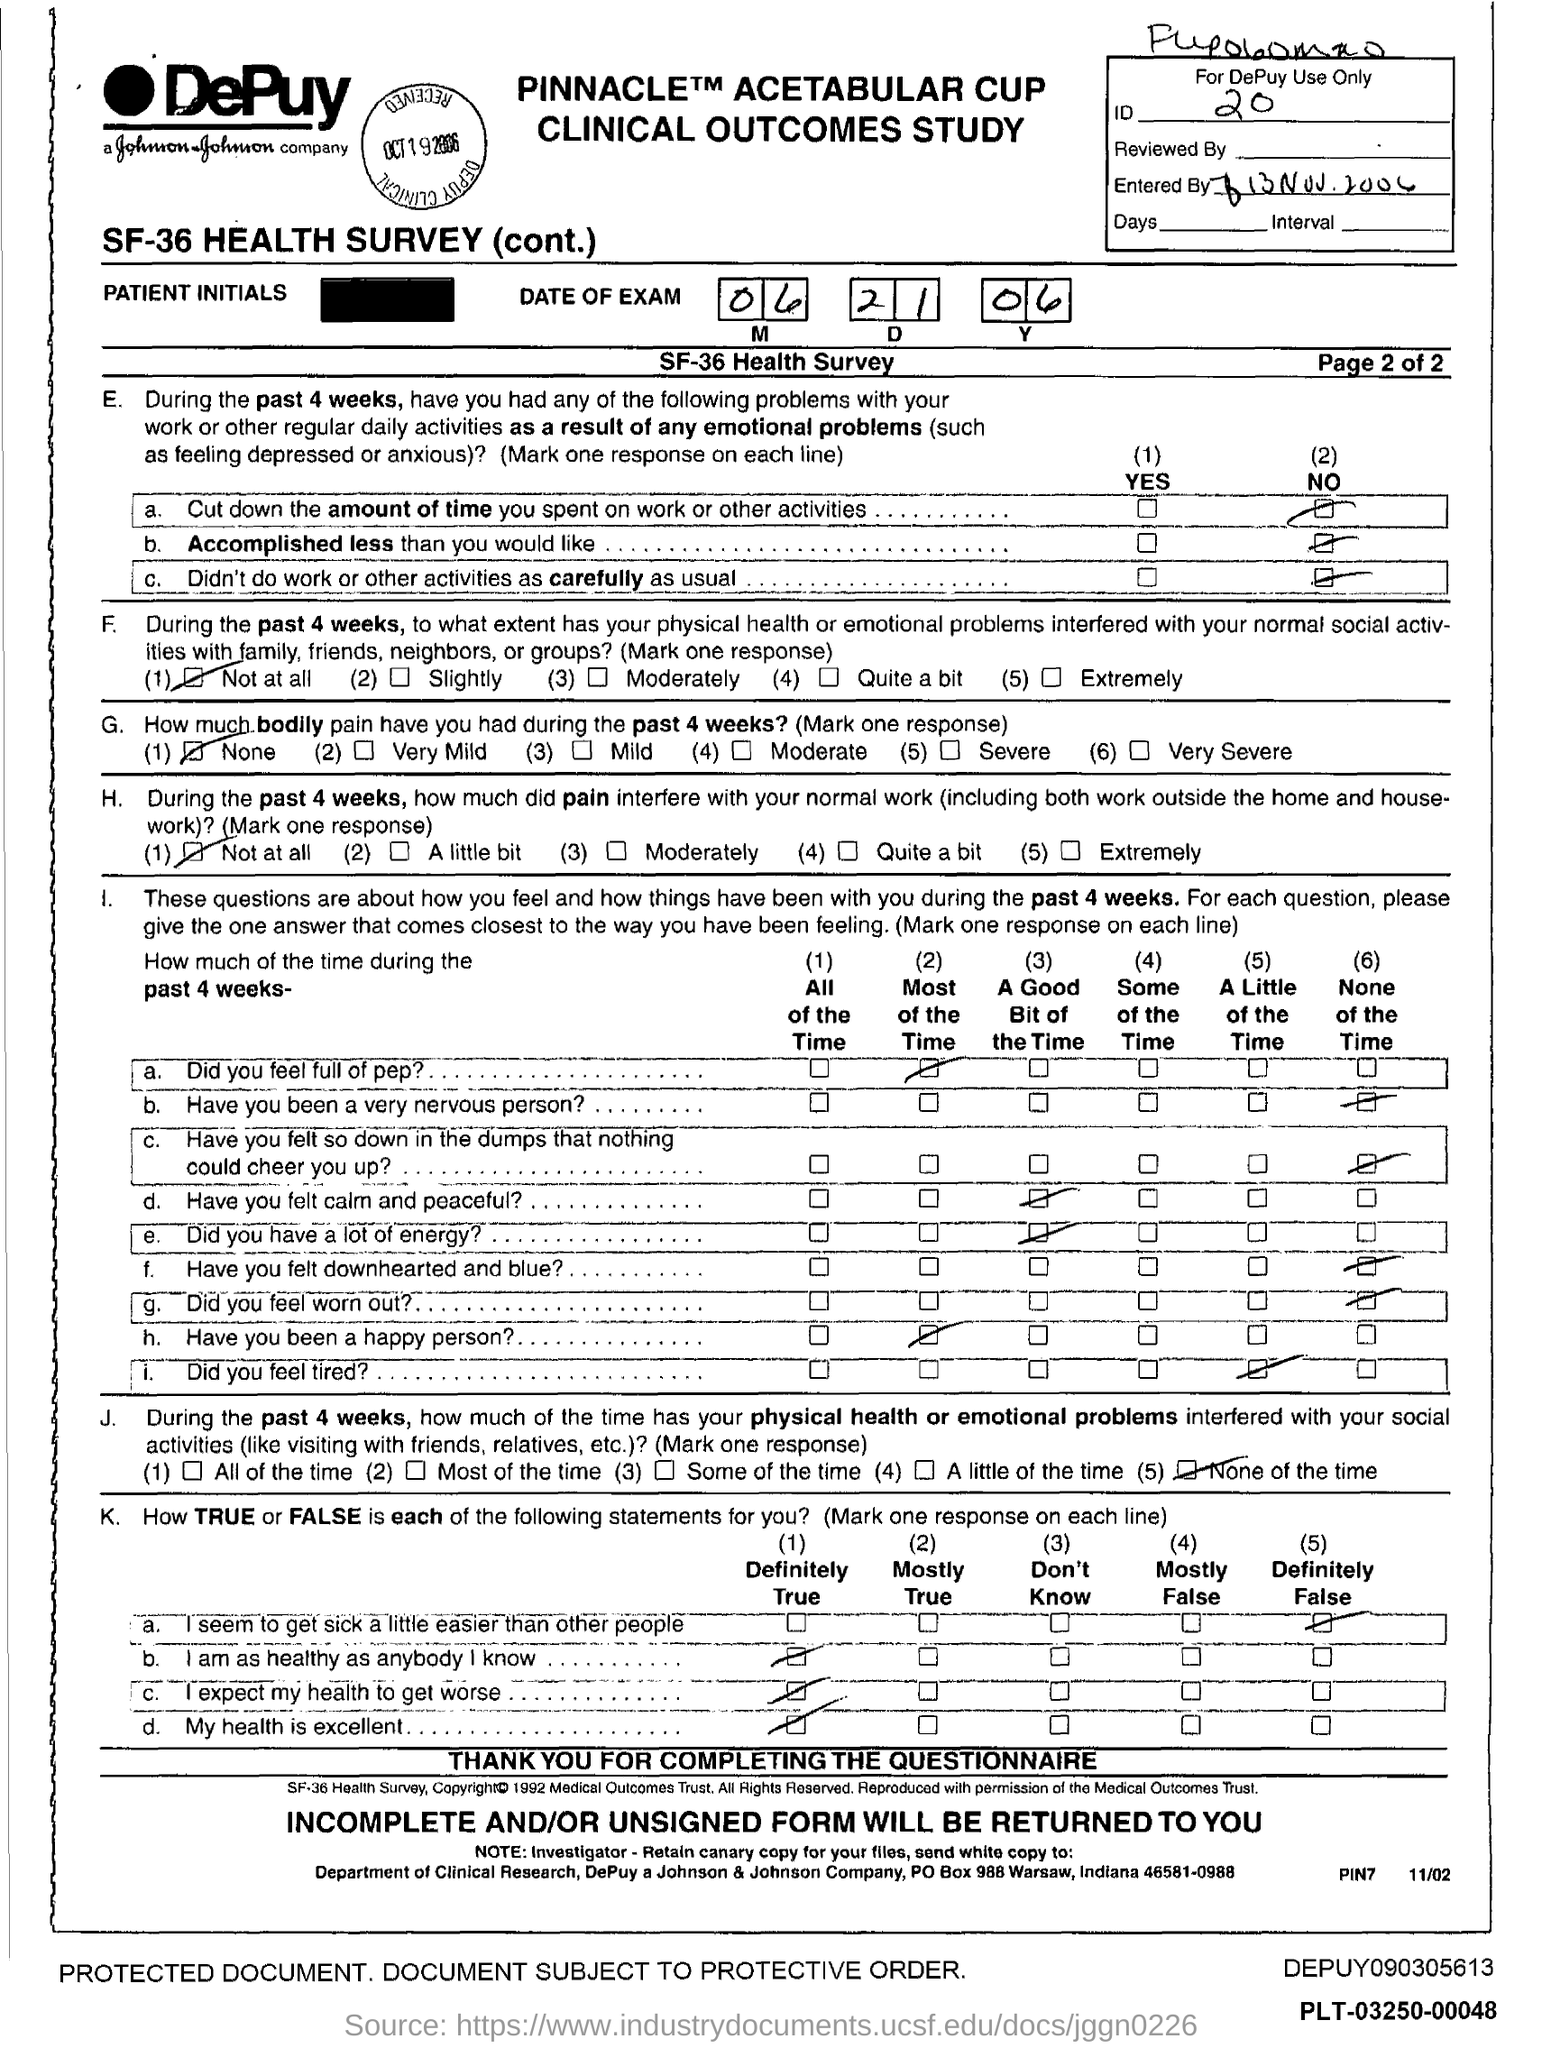What is the id no.?
Offer a terse response. 20. In which state is johnson & johnson company at?
Your answer should be compact. Indiana. What is the po box no. johnson & johnson company ?
Give a very brief answer. 988. 